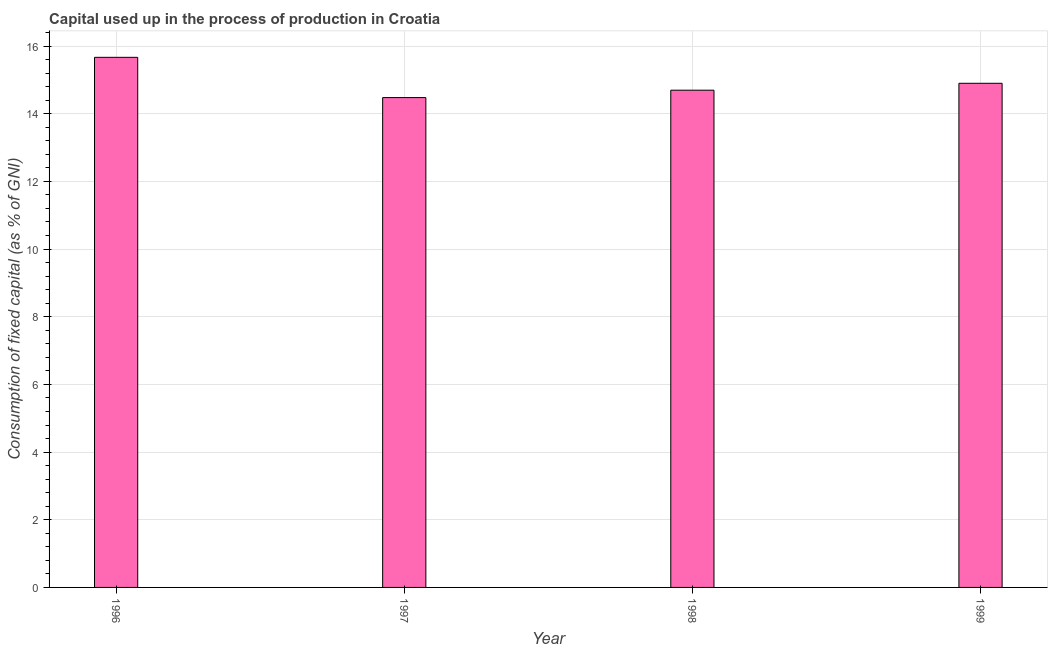Does the graph contain grids?
Your response must be concise. Yes. What is the title of the graph?
Provide a succinct answer. Capital used up in the process of production in Croatia. What is the label or title of the X-axis?
Make the answer very short. Year. What is the label or title of the Y-axis?
Ensure brevity in your answer.  Consumption of fixed capital (as % of GNI). What is the consumption of fixed capital in 1996?
Your answer should be very brief. 15.67. Across all years, what is the maximum consumption of fixed capital?
Your answer should be compact. 15.67. Across all years, what is the minimum consumption of fixed capital?
Provide a succinct answer. 14.48. In which year was the consumption of fixed capital minimum?
Your answer should be very brief. 1997. What is the sum of the consumption of fixed capital?
Give a very brief answer. 59.74. What is the difference between the consumption of fixed capital in 1996 and 1997?
Your answer should be compact. 1.19. What is the average consumption of fixed capital per year?
Your answer should be very brief. 14.93. What is the median consumption of fixed capital?
Your answer should be very brief. 14.8. Do a majority of the years between 1997 and 1996 (inclusive) have consumption of fixed capital greater than 1.6 %?
Make the answer very short. No. What is the ratio of the consumption of fixed capital in 1997 to that in 1998?
Your answer should be compact. 0.98. What is the difference between the highest and the second highest consumption of fixed capital?
Your response must be concise. 0.77. Is the sum of the consumption of fixed capital in 1996 and 1997 greater than the maximum consumption of fixed capital across all years?
Your answer should be compact. Yes. What is the difference between the highest and the lowest consumption of fixed capital?
Make the answer very short. 1.19. How many bars are there?
Make the answer very short. 4. Are all the bars in the graph horizontal?
Provide a short and direct response. No. Are the values on the major ticks of Y-axis written in scientific E-notation?
Offer a terse response. No. What is the Consumption of fixed capital (as % of GNI) in 1996?
Ensure brevity in your answer.  15.67. What is the Consumption of fixed capital (as % of GNI) in 1997?
Provide a short and direct response. 14.48. What is the Consumption of fixed capital (as % of GNI) of 1998?
Provide a succinct answer. 14.69. What is the Consumption of fixed capital (as % of GNI) in 1999?
Your answer should be compact. 14.9. What is the difference between the Consumption of fixed capital (as % of GNI) in 1996 and 1997?
Provide a short and direct response. 1.19. What is the difference between the Consumption of fixed capital (as % of GNI) in 1996 and 1998?
Your answer should be compact. 0.97. What is the difference between the Consumption of fixed capital (as % of GNI) in 1996 and 1999?
Your answer should be compact. 0.77. What is the difference between the Consumption of fixed capital (as % of GNI) in 1997 and 1998?
Provide a succinct answer. -0.22. What is the difference between the Consumption of fixed capital (as % of GNI) in 1997 and 1999?
Give a very brief answer. -0.42. What is the difference between the Consumption of fixed capital (as % of GNI) in 1998 and 1999?
Your answer should be very brief. -0.2. What is the ratio of the Consumption of fixed capital (as % of GNI) in 1996 to that in 1997?
Provide a succinct answer. 1.08. What is the ratio of the Consumption of fixed capital (as % of GNI) in 1996 to that in 1998?
Offer a very short reply. 1.07. What is the ratio of the Consumption of fixed capital (as % of GNI) in 1996 to that in 1999?
Your answer should be very brief. 1.05. 